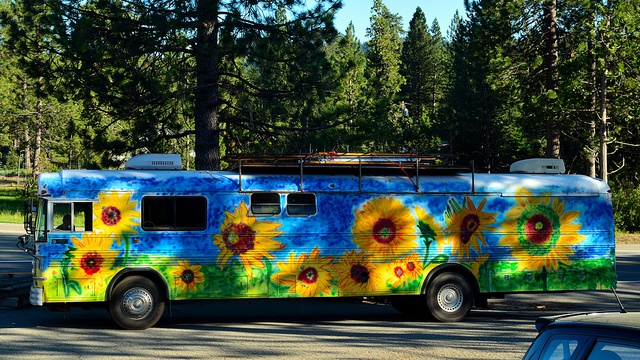Describe the objects in this image and their specific colors. I can see bus in turquoise, black, blue, darkgreen, and olive tones, car in turquoise, black, navy, blue, and darkgray tones, and people in turquoise, black, darkgreen, gray, and olive tones in this image. 